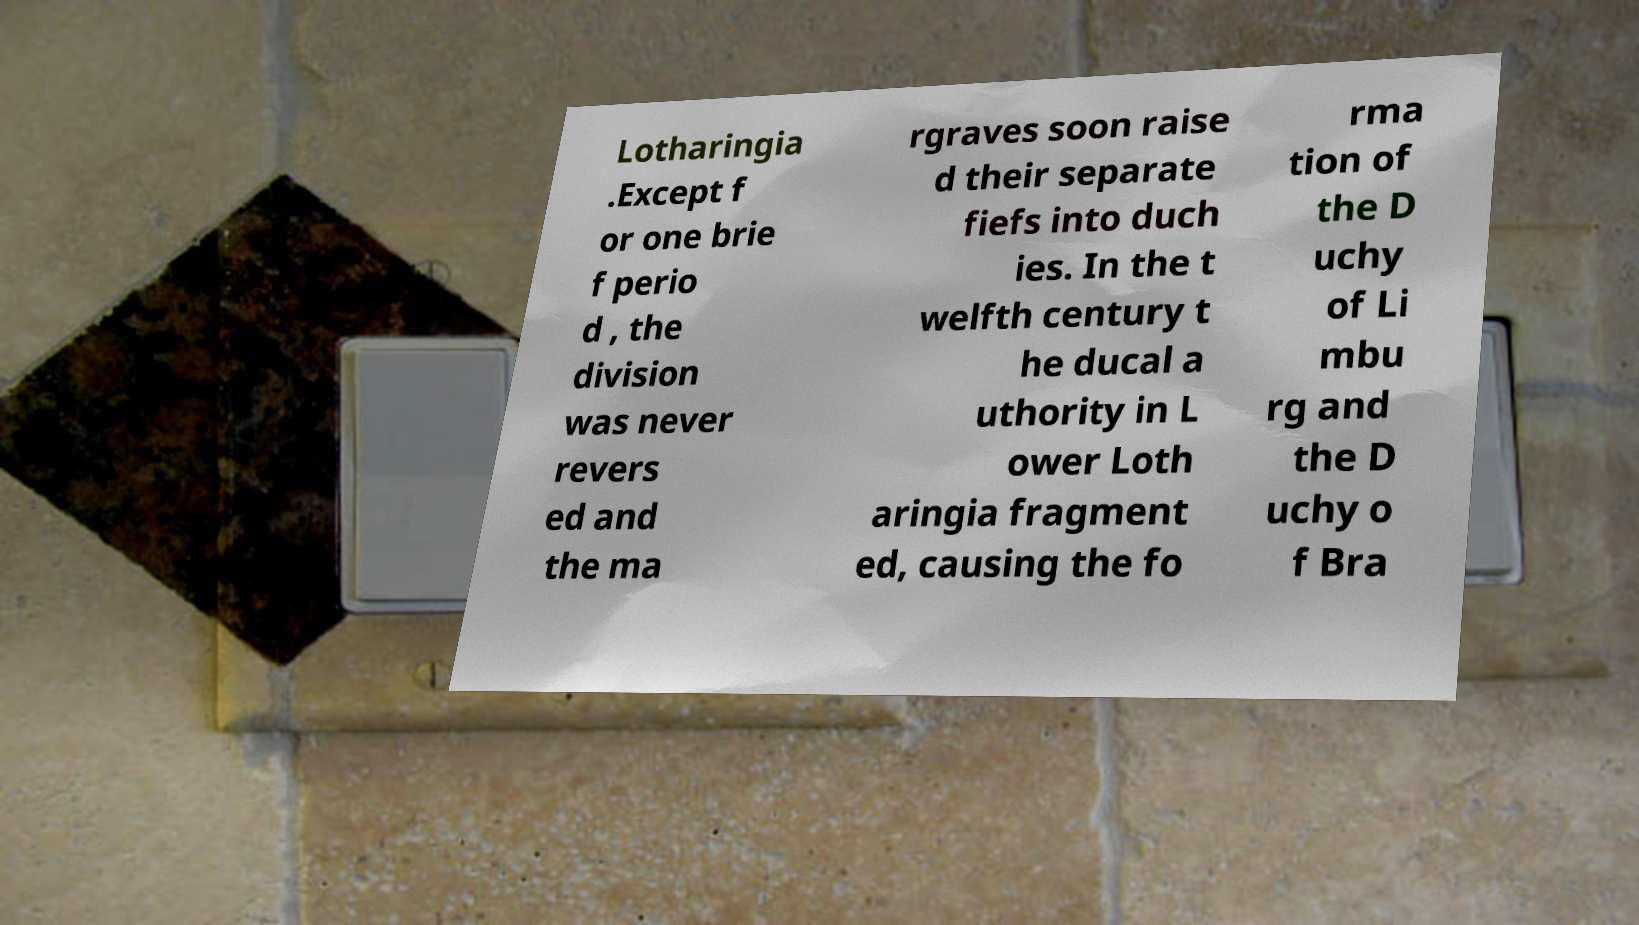Could you assist in decoding the text presented in this image and type it out clearly? Lotharingia .Except f or one brie f perio d , the division was never revers ed and the ma rgraves soon raise d their separate fiefs into duch ies. In the t welfth century t he ducal a uthority in L ower Loth aringia fragment ed, causing the fo rma tion of the D uchy of Li mbu rg and the D uchy o f Bra 